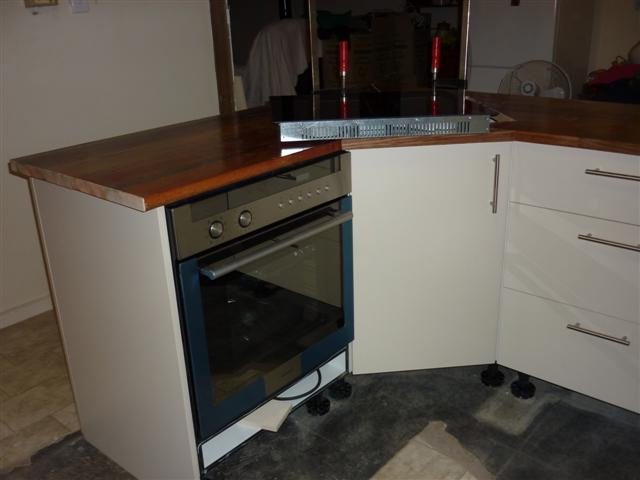Does this look like a freezer?
Be succinct. No. What color is the oven?
Quick response, please. Black. What is the top of this appliance made of?
Concise answer only. Wood. What color is the fan?
Write a very short answer. White. What is the stainless steel item?
Short answer required. Oven. How many candles are in this scene?
Be succinct. 2. What color is the counter in the kitchen?
Quick response, please. Brown. What is the brand of oven in the kitchen?
Concise answer only. Ge. 